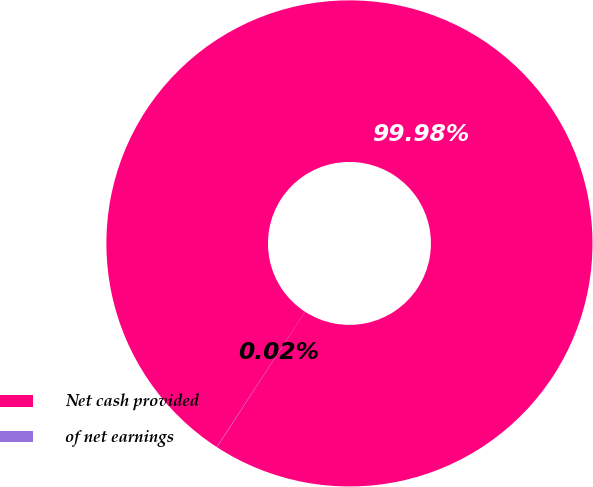Convert chart to OTSL. <chart><loc_0><loc_0><loc_500><loc_500><pie_chart><fcel>Net cash provided<fcel>of net earnings<nl><fcel>99.98%<fcel>0.02%<nl></chart> 